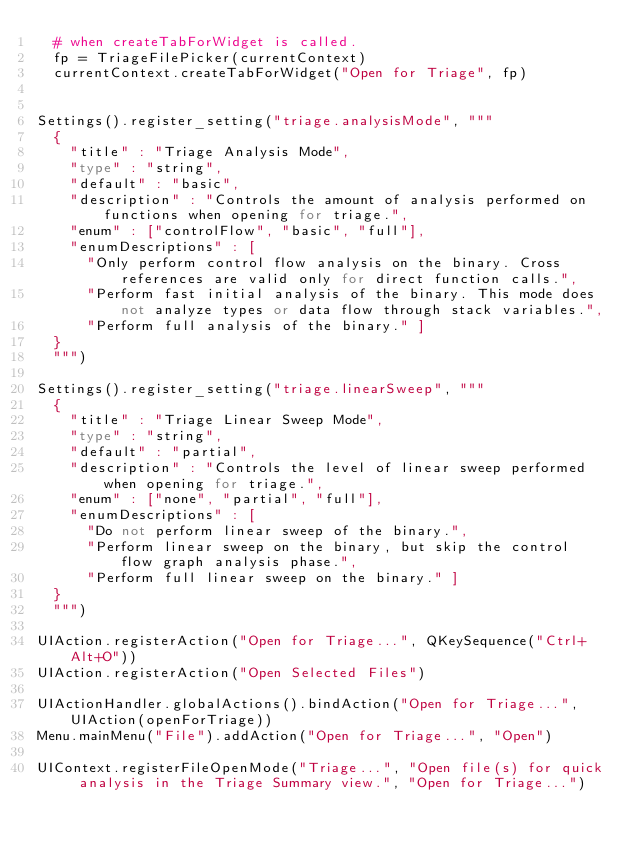Convert code to text. <code><loc_0><loc_0><loc_500><loc_500><_Python_>	# when createTabForWidget is called.
	fp = TriageFilePicker(currentContext)
	currentContext.createTabForWidget("Open for Triage", fp)


Settings().register_setting("triage.analysisMode", """
	{
		"title" : "Triage Analysis Mode",
		"type" : "string",
		"default" : "basic",
		"description" : "Controls the amount of analysis performed on functions when opening for triage.",
		"enum" : ["controlFlow", "basic", "full"],
		"enumDescriptions" : [
			"Only perform control flow analysis on the binary. Cross references are valid only for direct function calls.",
			"Perform fast initial analysis of the binary. This mode does not analyze types or data flow through stack variables.",
			"Perform full analysis of the binary." ]
	}
	""")

Settings().register_setting("triage.linearSweep", """
	{
		"title" : "Triage Linear Sweep Mode",
		"type" : "string",
		"default" : "partial",
		"description" : "Controls the level of linear sweep performed when opening for triage.",
		"enum" : ["none", "partial", "full"],
		"enumDescriptions" : [
			"Do not perform linear sweep of the binary.",
			"Perform linear sweep on the binary, but skip the control flow graph analysis phase.",
			"Perform full linear sweep on the binary." ]
	}
	""")

UIAction.registerAction("Open for Triage...", QKeySequence("Ctrl+Alt+O"))
UIAction.registerAction("Open Selected Files")

UIActionHandler.globalActions().bindAction("Open for Triage...", UIAction(openForTriage))
Menu.mainMenu("File").addAction("Open for Triage...", "Open")

UIContext.registerFileOpenMode("Triage...", "Open file(s) for quick analysis in the Triage Summary view.", "Open for Triage...")
</code> 